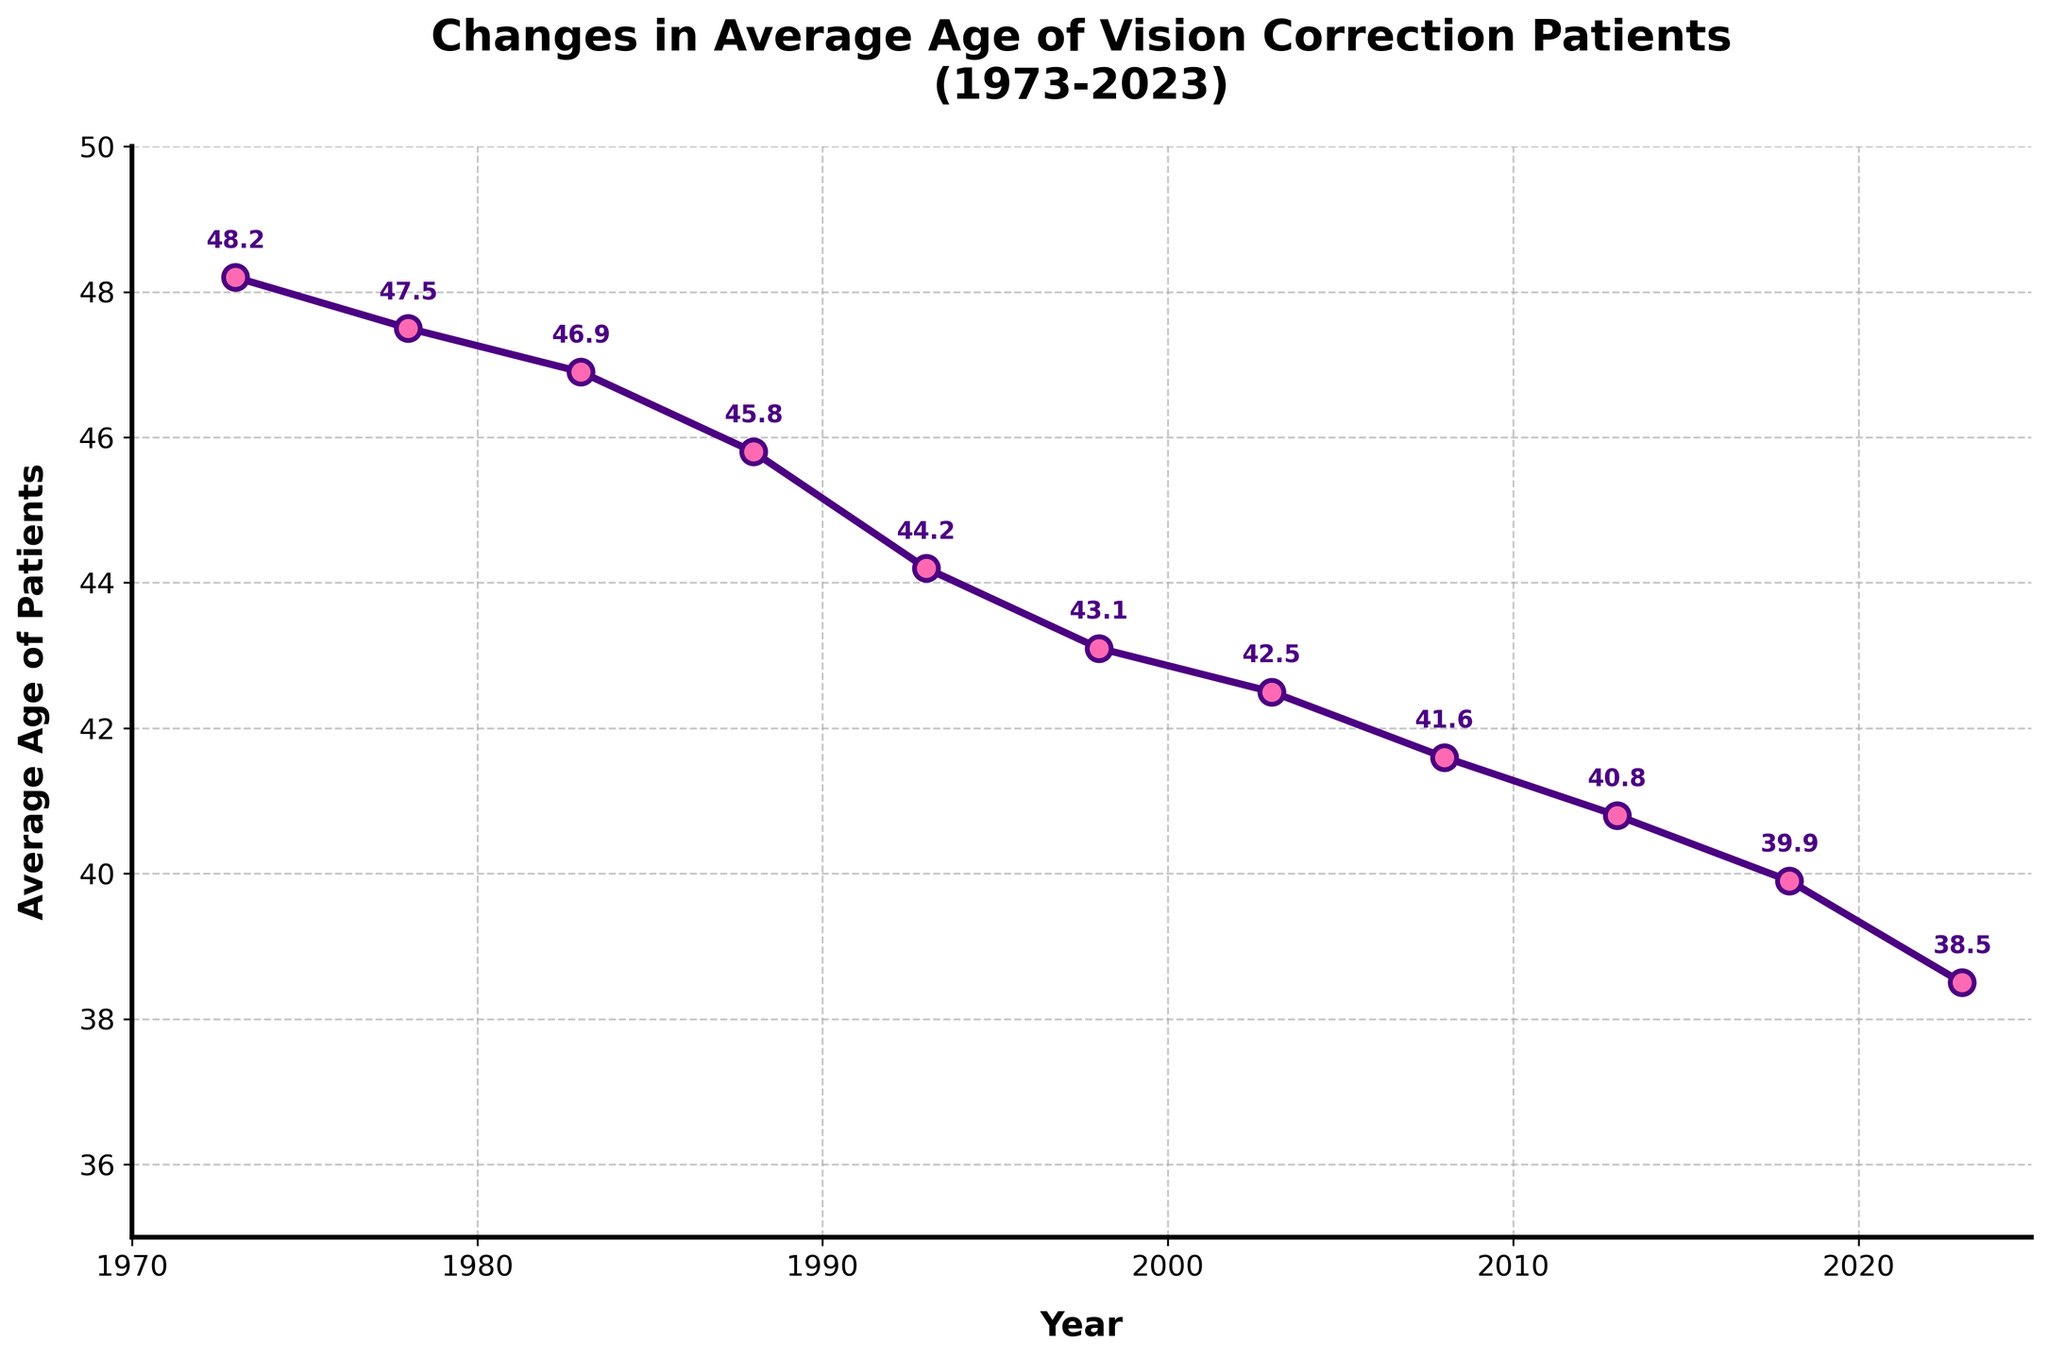What is the title of the time series plot? The title is written at the top of the plot. It indicates what the plot is about.
Answer: Changes in Average Age of Vision Correction Patients (1973-2023) What were the average age of patients in 1988? To find the answer, look for the data point corresponding to the year 1988 on the x-axis and read the value on the y-axis.
Answer: 45.8 How has the average age of patients changed from 1973 to 2023? Identify the data points for 1973 and 2023, then compare the average ages.
Answer: The average age decreased from 48.2 to 38.5 During which decade did the average age of patients decrease the most? Compare the change in the average age for each decade: 1973-1983, 1983-1993, 1993-2003, 2003-2013, 2013-2023. Subtract the initial year's average age from the final year's average age for each decade for comparison.
Answer: The 1980s (45.8 - 44.2 = 1.6) How many data points are represented on the plot? Count the number of years listed on the x-axis, which corresponds to the number of data points.
Answer: 11 What is the overall trend shown in the plot? Observe the direction of the line connecting the data points throughout the timeframe.
Answer: The average age of patients is decreasing Which year had the lowest average age of patients? Locate the data point with the smallest y-axis value.
Answer: 2023 By how much did the average age decrease from 2008 to 2013? Identify the average ages in 2008 (41.6) and 2013 (40.8), then subtract the 2013 value from the 2008 value.
Answer: 0.8 What is the average of the data points provided for the years 1973, 1983, and 1993? Locate the average ages for these years: 1973 (48.2), 1983 (46.9), and 1993 (44.2). Sum them up and divide by the number of years (3).
Answer: (48.2 + 46.9 + 44.2) / 3 = 46.43 Which two consecutive data points show the largest drop in average age? Calculate the difference between consecutive yearly average ages and find the greatest decrease. Examine years: 1973-1978, 1978-1983, etc.
Answer: 1993 to 1998 (44.2 - 43.1 = 1.1) 